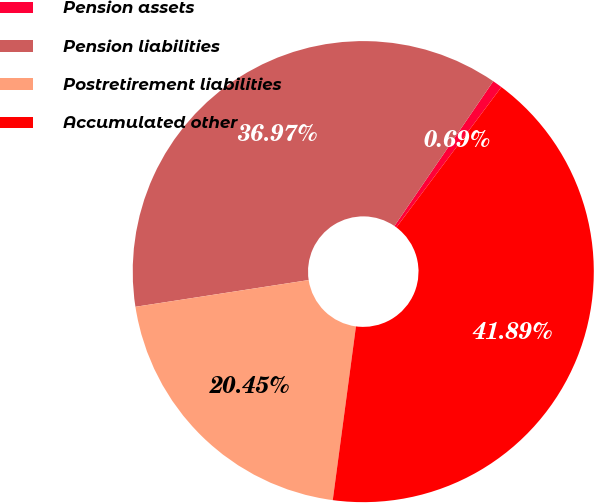Convert chart to OTSL. <chart><loc_0><loc_0><loc_500><loc_500><pie_chart><fcel>Pension assets<fcel>Pension liabilities<fcel>Postretirement liabilities<fcel>Accumulated other<nl><fcel>0.69%<fcel>36.97%<fcel>20.45%<fcel>41.89%<nl></chart> 